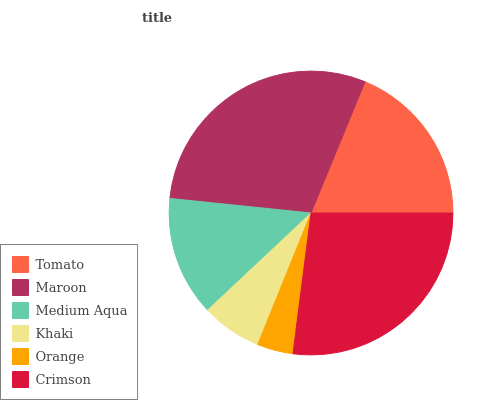Is Orange the minimum?
Answer yes or no. Yes. Is Maroon the maximum?
Answer yes or no. Yes. Is Medium Aqua the minimum?
Answer yes or no. No. Is Medium Aqua the maximum?
Answer yes or no. No. Is Maroon greater than Medium Aqua?
Answer yes or no. Yes. Is Medium Aqua less than Maroon?
Answer yes or no. Yes. Is Medium Aqua greater than Maroon?
Answer yes or no. No. Is Maroon less than Medium Aqua?
Answer yes or no. No. Is Tomato the high median?
Answer yes or no. Yes. Is Medium Aqua the low median?
Answer yes or no. Yes. Is Khaki the high median?
Answer yes or no. No. Is Khaki the low median?
Answer yes or no. No. 